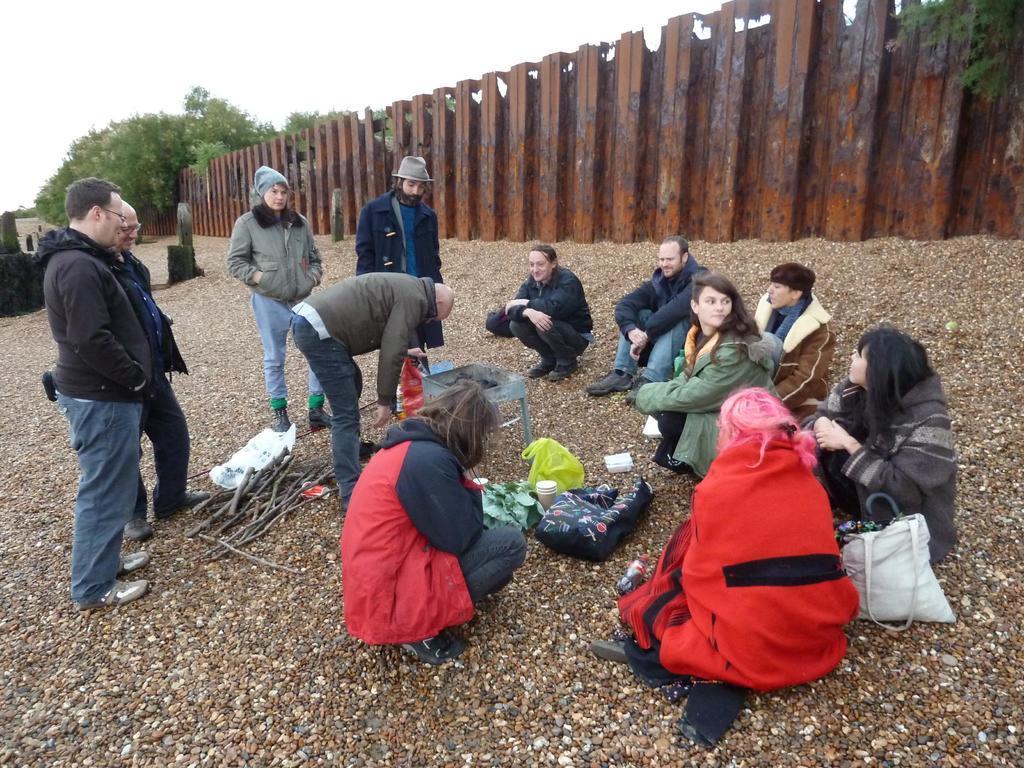How would you summarize this image in a sentence or two? In this image, there are a few people. We can see the ground covered with some objects like wooden sticks and a bag. We can see the fence and some trees. We can also see the sky. 